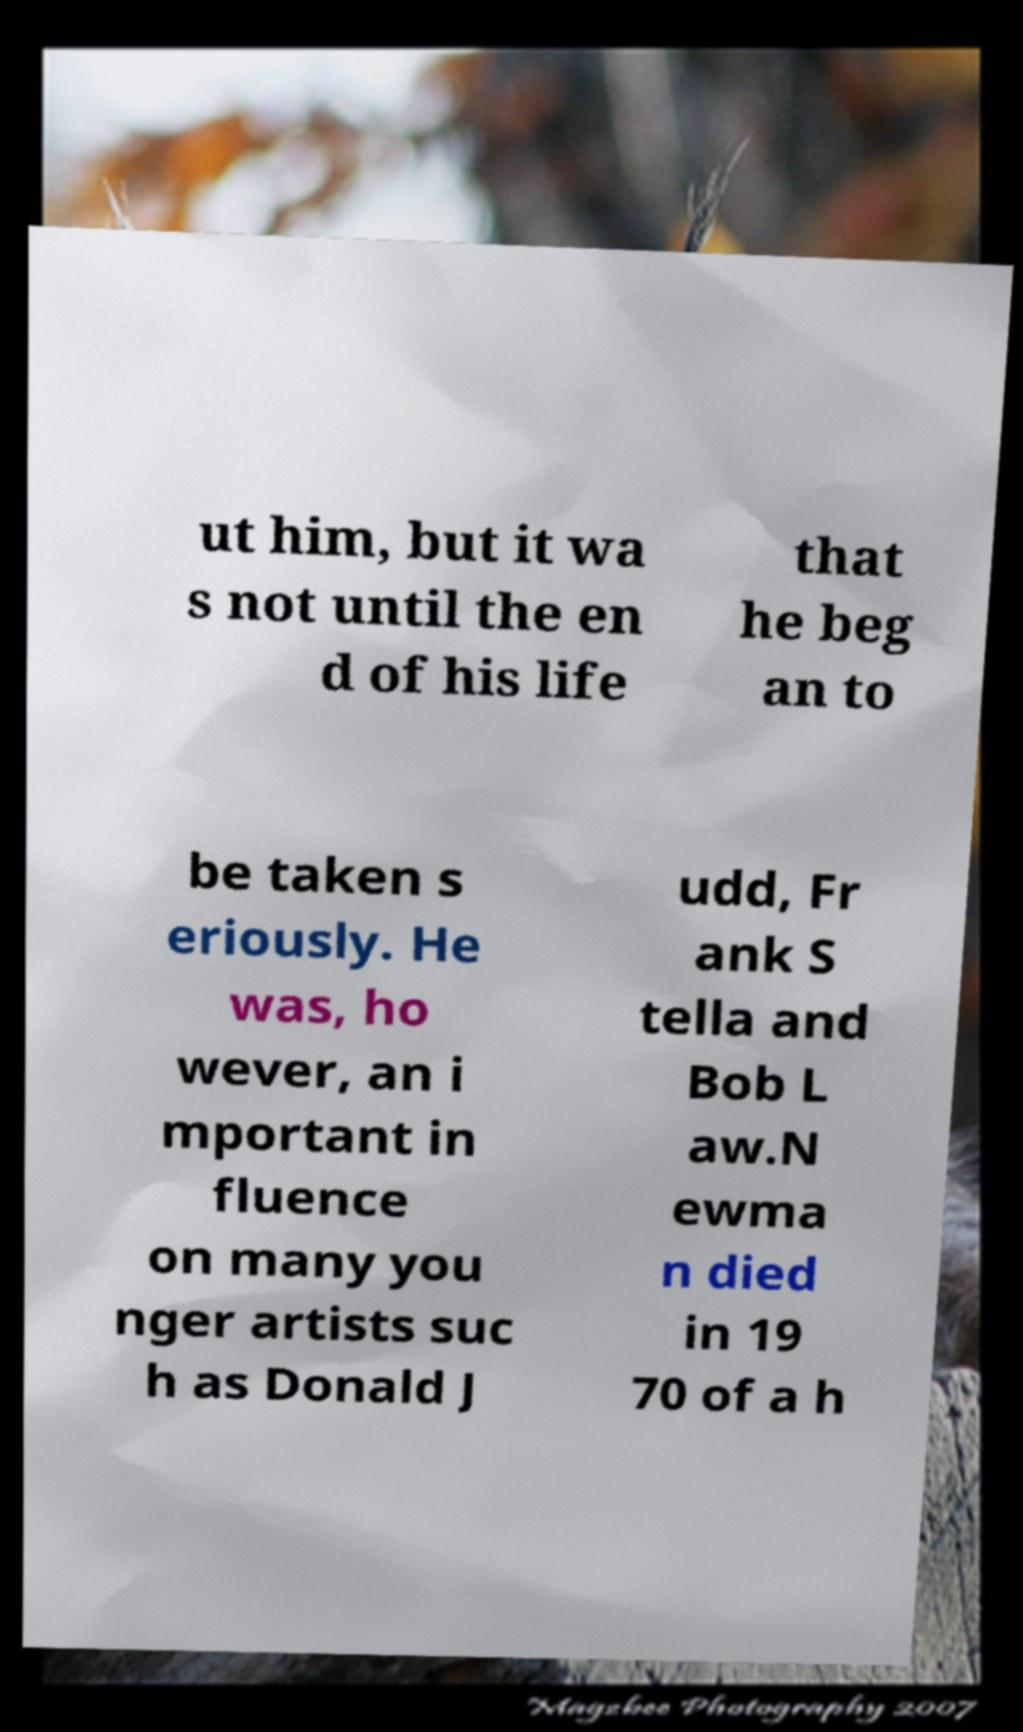There's text embedded in this image that I need extracted. Can you transcribe it verbatim? ut him, but it wa s not until the en d of his life that he beg an to be taken s eriously. He was, ho wever, an i mportant in fluence on many you nger artists suc h as Donald J udd, Fr ank S tella and Bob L aw.N ewma n died in 19 70 of a h 